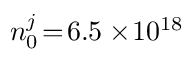<formula> <loc_0><loc_0><loc_500><loc_500>n _ { 0 } ^ { j } \, = \, 6 . 5 \times \, 1 0 ^ { 1 8 }</formula> 